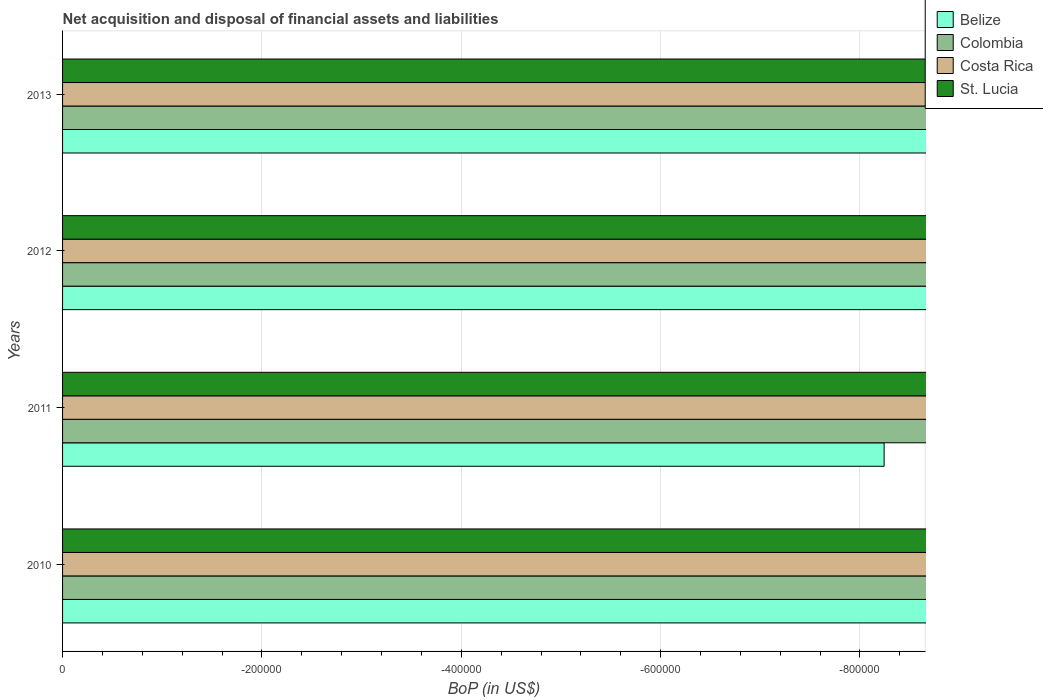Are the number of bars per tick equal to the number of legend labels?
Ensure brevity in your answer.  No. How many bars are there on the 3rd tick from the bottom?
Make the answer very short. 0. What is the label of the 2nd group of bars from the top?
Offer a very short reply. 2012. What is the difference between the Balance of Payments in Belize in 2013 and the Balance of Payments in Colombia in 2012?
Provide a succinct answer. 0. Is it the case that in every year, the sum of the Balance of Payments in Colombia and Balance of Payments in Costa Rica is greater than the Balance of Payments in St. Lucia?
Your answer should be compact. No. Are all the bars in the graph horizontal?
Keep it short and to the point. Yes. What is the difference between two consecutive major ticks on the X-axis?
Your answer should be very brief. 2.00e+05. Are the values on the major ticks of X-axis written in scientific E-notation?
Your response must be concise. No. Does the graph contain grids?
Offer a very short reply. Yes. How many legend labels are there?
Provide a succinct answer. 4. What is the title of the graph?
Offer a terse response. Net acquisition and disposal of financial assets and liabilities. What is the label or title of the X-axis?
Keep it short and to the point. BoP (in US$). What is the BoP (in US$) in Belize in 2010?
Your answer should be very brief. 0. What is the BoP (in US$) of Colombia in 2010?
Ensure brevity in your answer.  0. What is the BoP (in US$) of St. Lucia in 2010?
Give a very brief answer. 0. What is the BoP (in US$) of Colombia in 2011?
Your answer should be compact. 0. What is the BoP (in US$) of Costa Rica in 2011?
Your answer should be very brief. 0. What is the BoP (in US$) of St. Lucia in 2011?
Your answer should be very brief. 0. What is the BoP (in US$) of Belize in 2012?
Give a very brief answer. 0. What is the BoP (in US$) of Costa Rica in 2012?
Provide a short and direct response. 0. What is the BoP (in US$) of Belize in 2013?
Keep it short and to the point. 0. What is the BoP (in US$) in Costa Rica in 2013?
Provide a short and direct response. 0. What is the BoP (in US$) of St. Lucia in 2013?
Provide a short and direct response. 0. What is the total BoP (in US$) of Colombia in the graph?
Give a very brief answer. 0. What is the total BoP (in US$) in St. Lucia in the graph?
Ensure brevity in your answer.  0. What is the average BoP (in US$) of Belize per year?
Your answer should be very brief. 0. What is the average BoP (in US$) in Colombia per year?
Provide a succinct answer. 0. What is the average BoP (in US$) of Costa Rica per year?
Provide a short and direct response. 0. What is the average BoP (in US$) of St. Lucia per year?
Offer a very short reply. 0. 